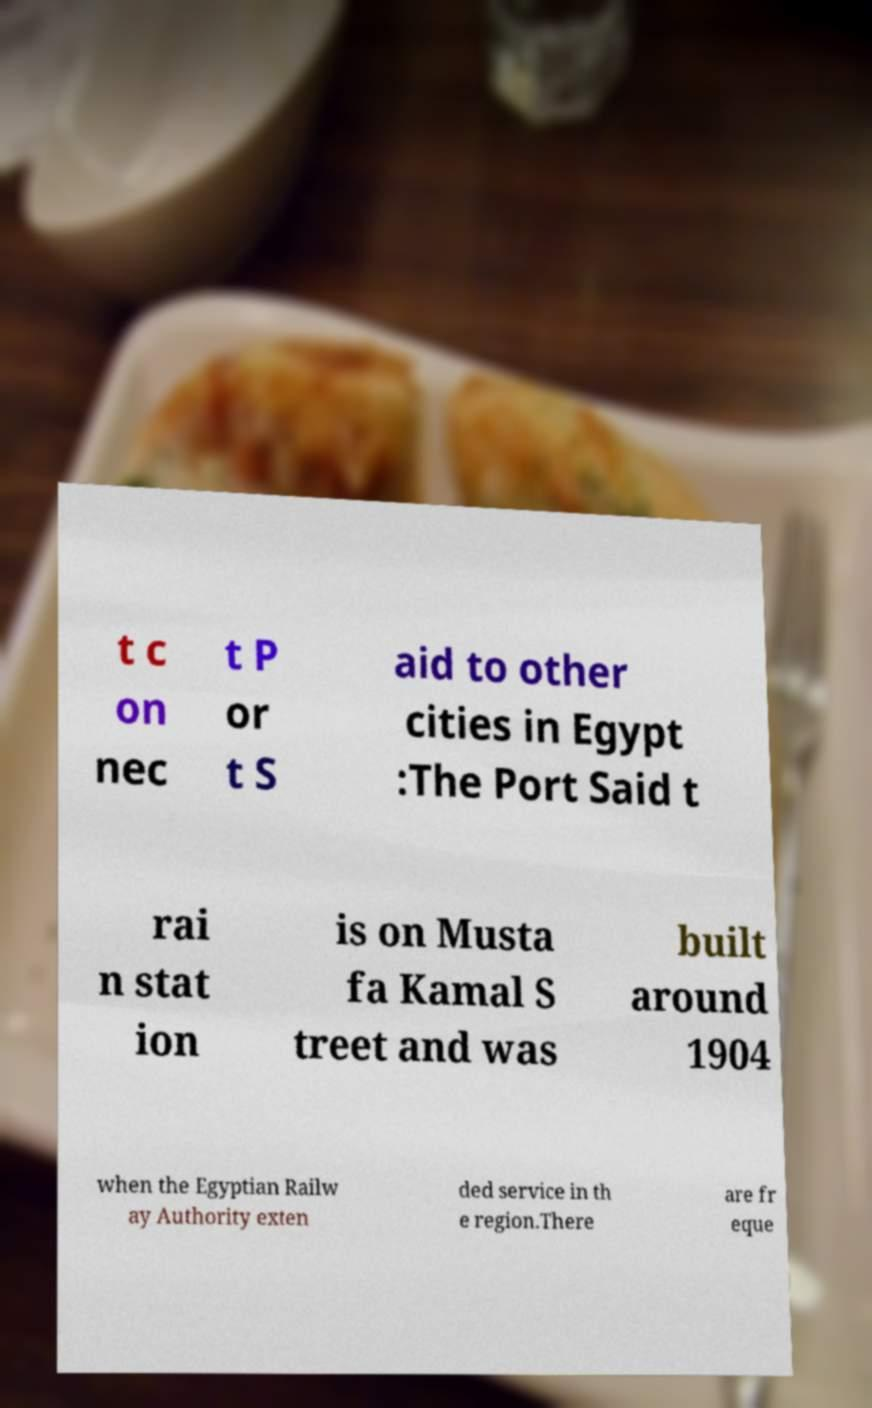Please read and relay the text visible in this image. What does it say? t c on nec t P or t S aid to other cities in Egypt :The Port Said t rai n stat ion is on Musta fa Kamal S treet and was built around 1904 when the Egyptian Railw ay Authority exten ded service in th e region.There are fr eque 